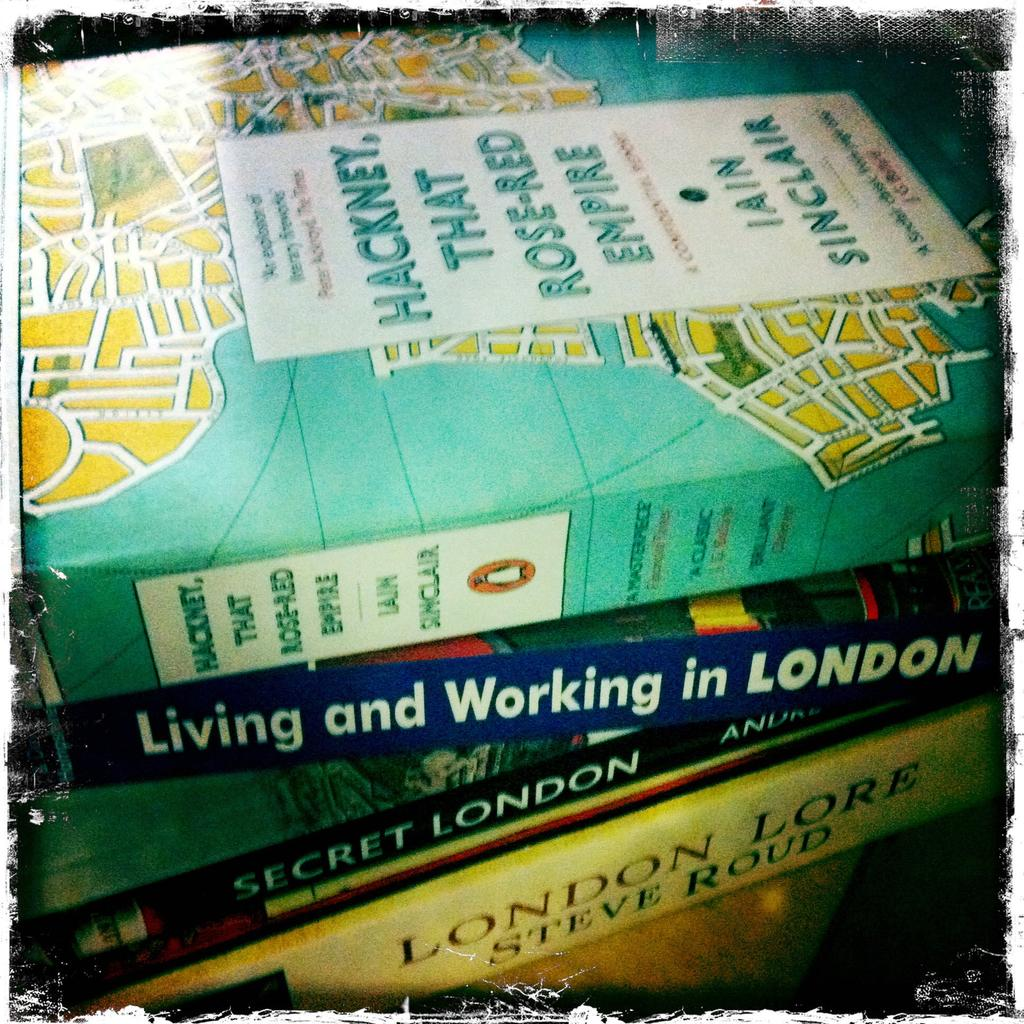<image>
Present a compact description of the photo's key features. A stack of books with London Lore by Steve Roud on the bottom of the pile. 